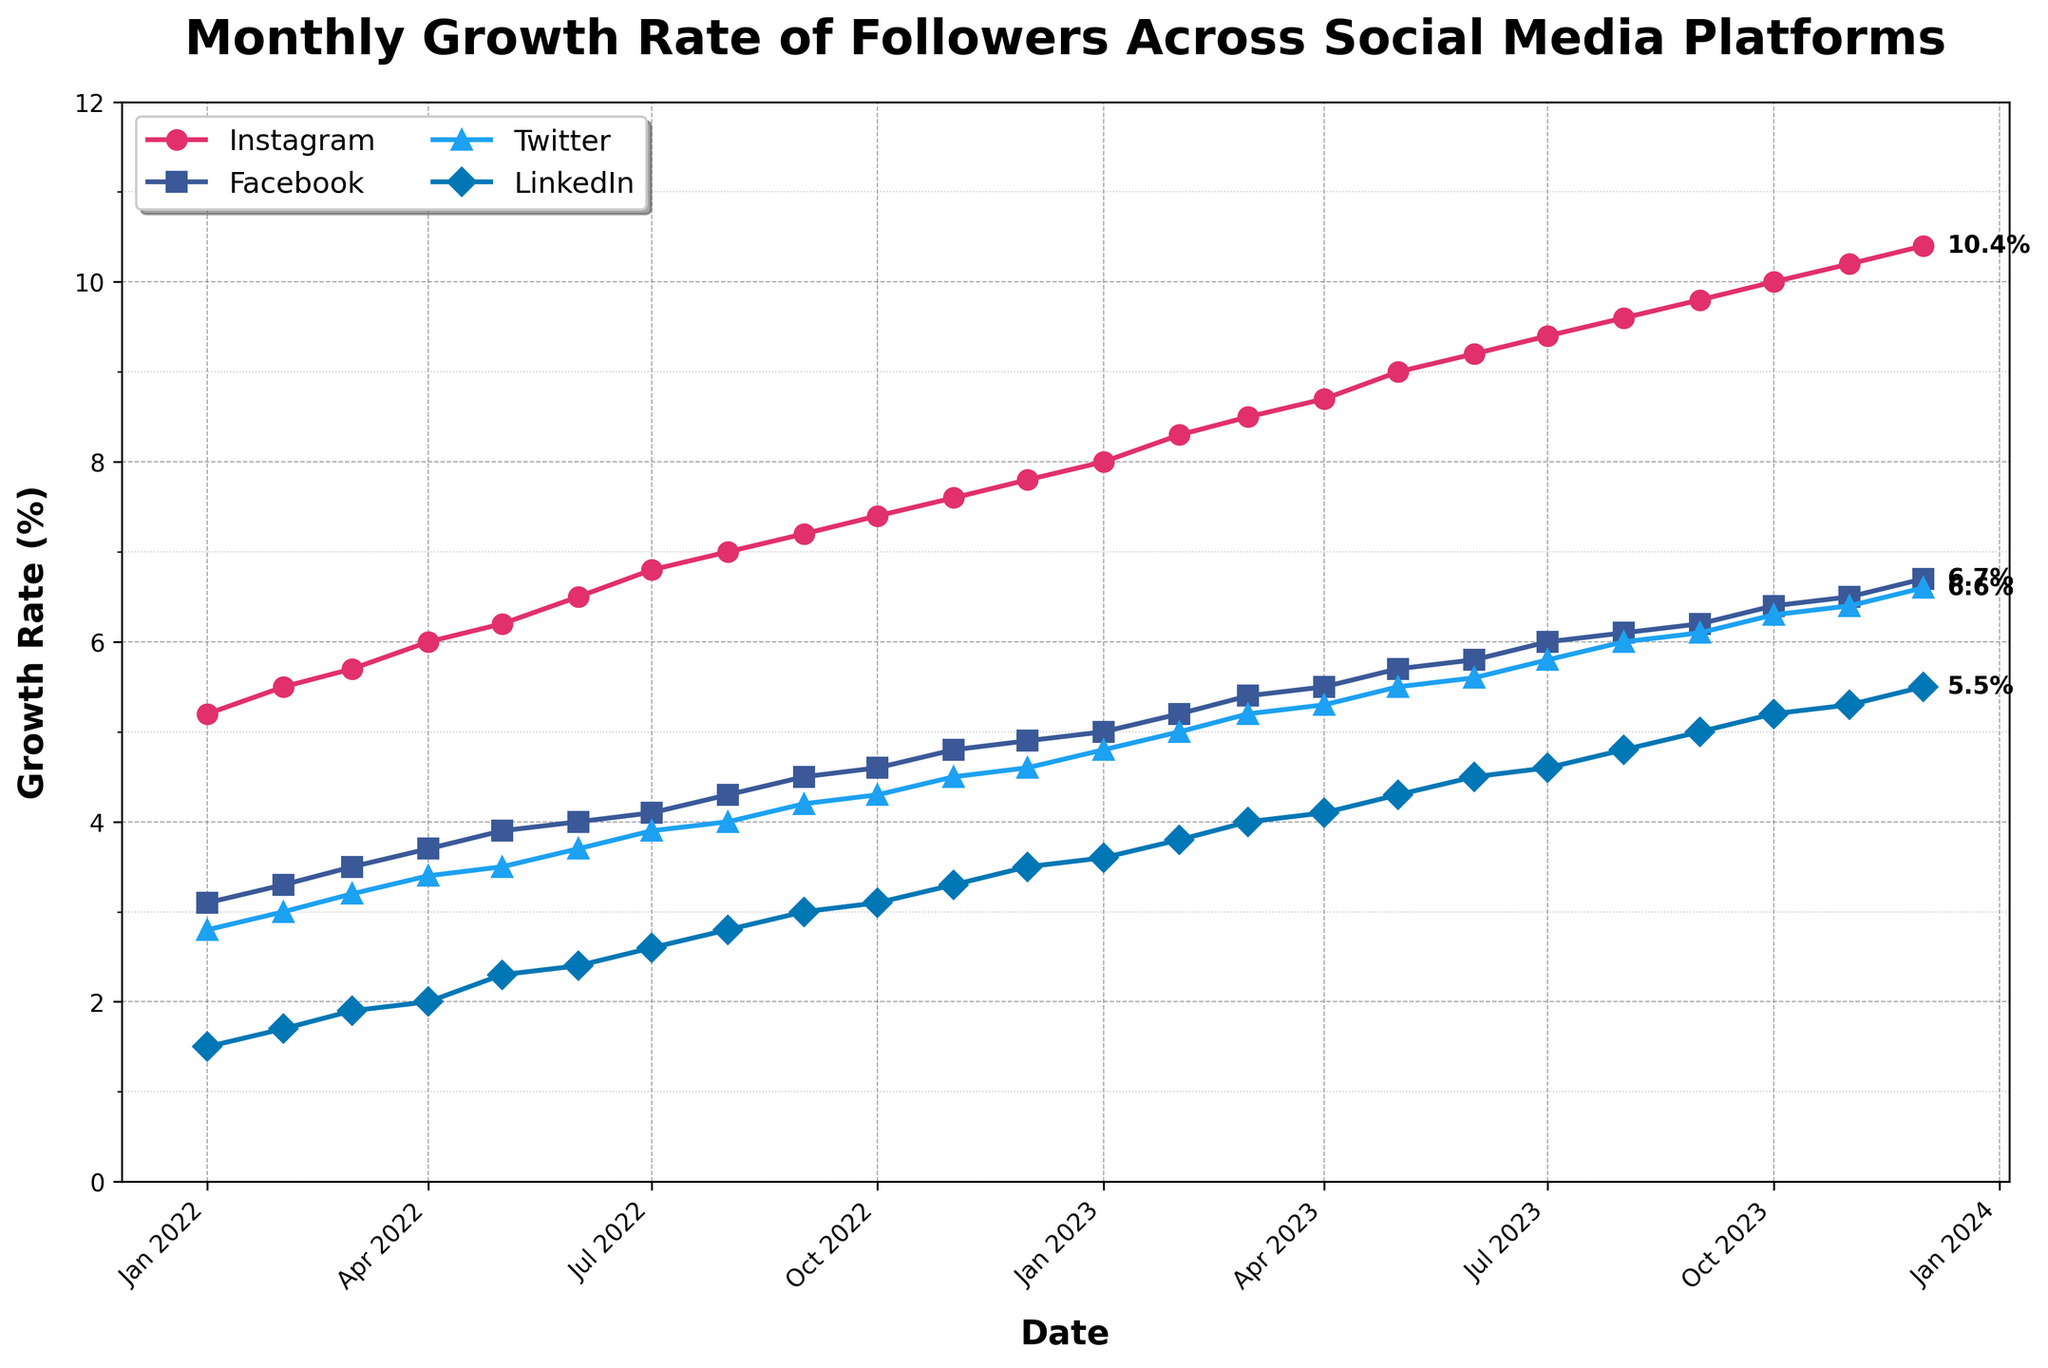Which social media platform has the highest growth rate in January 2022? Look at the data points plotted in January 2022 for each platform. The highest y-value on the plot corresponds to Instagram.
Answer: Instagram What is the title of the figure? The title of the figure is usually displayed at the top, in bold text.
Answer: Monthly Growth Rate of Followers Across Social Media Platforms How has the growth rate for LinkedIn changed from January 2022 to December 2023? Find the data points for LinkedIn in January 2022 and December 2023 and subtract the former from the latter to get the change in growth rate. LinkedIn was at 1.5% in January 2022 and 5.5% in December 2023. Hence, 5.5 - 1.5 = 4.
Answer: 4% Which platform surpasses the 6% growth rate first? By following the plot lines for each platform, note which color/marker crosses the 6% y-axis first, which happens for Instagram around June 2022.
Answer: Instagram During which month does Twitter reach a growth rate of 5%? Look for the point where the growth rate for Twitter reaches 5% on its line. This happens in February 2023.
Answer: February 2023 What is the growth rate for Facebook in July 2023 and how much has it increased since January 2022? Extract the value for Facebook in July 2023 (6.0%) and subtract the value from January 2022 (3.1%) to find the increase. The increase is 6.0 - 3.1 = 2.9%.
Answer: 2.9% How does Instagram's growth rate in December 2023 compare to Facebook's growth rate in the same month? Compare the values of Instagram and Facebook directly in December 2023, which are 10.4% and 6.7% respectively. Instagram is higher.
Answer: Instagram is higher Which two platforms show the closest growth rates in December 2022? By comparing the growth rates shown in plots for December 2022, the closest are Twitter and LinkedIn with rates of 6.6% and 5.5%, a difference of 1.
Answer: Twitter and LinkedIn What is the average growth rate of Instagram over the entire period? Sum all Instagram's monthly growth rates and divide by the number of months. 5.2 + 5.5 + ... + 10.4 = 107.5. The number of months is 24, so the average rate is 107.5 / 24 = 4.48.
Answer: 4.48 Between which two consecutive months does Facebook display the largest growth increase? Calculate the differences between consecutive months for Facebook's data and find the maximum increment. The largest increase is from July 2023 to August 2023 (6.1 - 5.8 = 0.3).
Answer: July 2023 to August 2023 